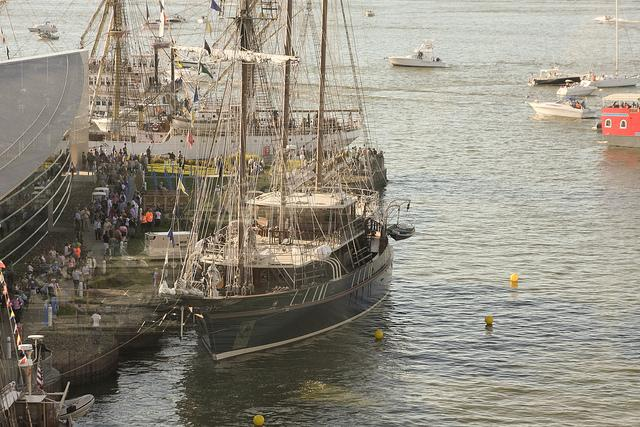What century of advancement might this boat belong to? Please explain your reasoning. 18th. The century is the 18th. 